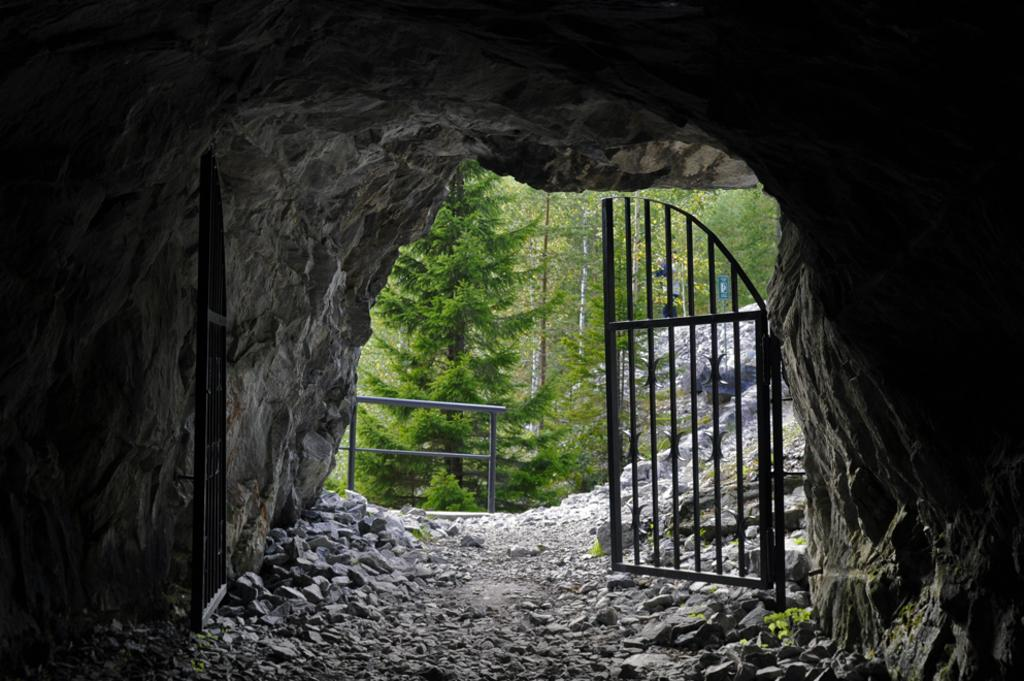What type of natural formation is present in the image? There is a cave in the image. What type of material can be seen in the image? There are stones in the image. What type of barrier is present in the image? There is an iron grill in the image. What type of vegetation is present in the image? There are trees in the image. Who is the creator of the trees in the image? The trees in the image are natural formations and do not have a specific creator. Can you describe how the stones walk in the image? The stones do not walk in the image; they are stationary. 